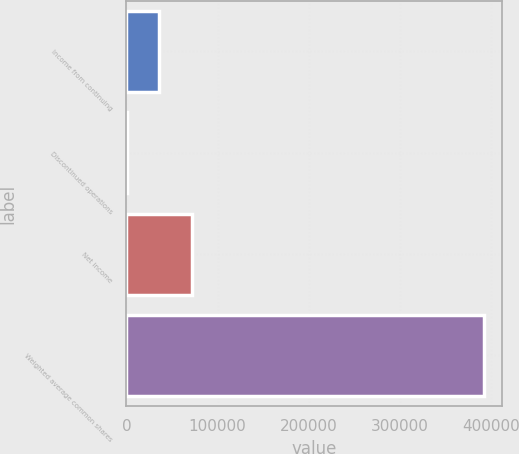<chart> <loc_0><loc_0><loc_500><loc_500><bar_chart><fcel>Income from continuing<fcel>Discontinued operations<fcel>Net income<fcel>Weighted average common shares<nl><fcel>35948.6<fcel>45<fcel>71852.2<fcel>391907<nl></chart> 